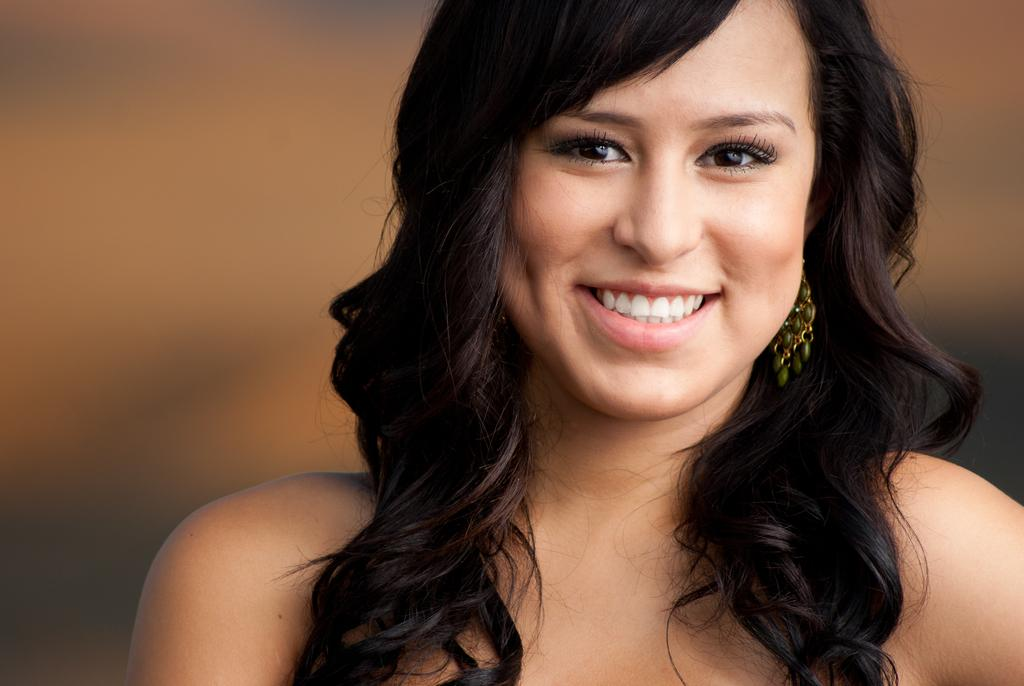What is the main subject of the image? There is a person in the image, but they are truncated. Can you describe the background of the image? The background of the image is blurred. What type of sugar is being used for writing on the bone in the image? There is no sugar, writing, or bone present in the image. 